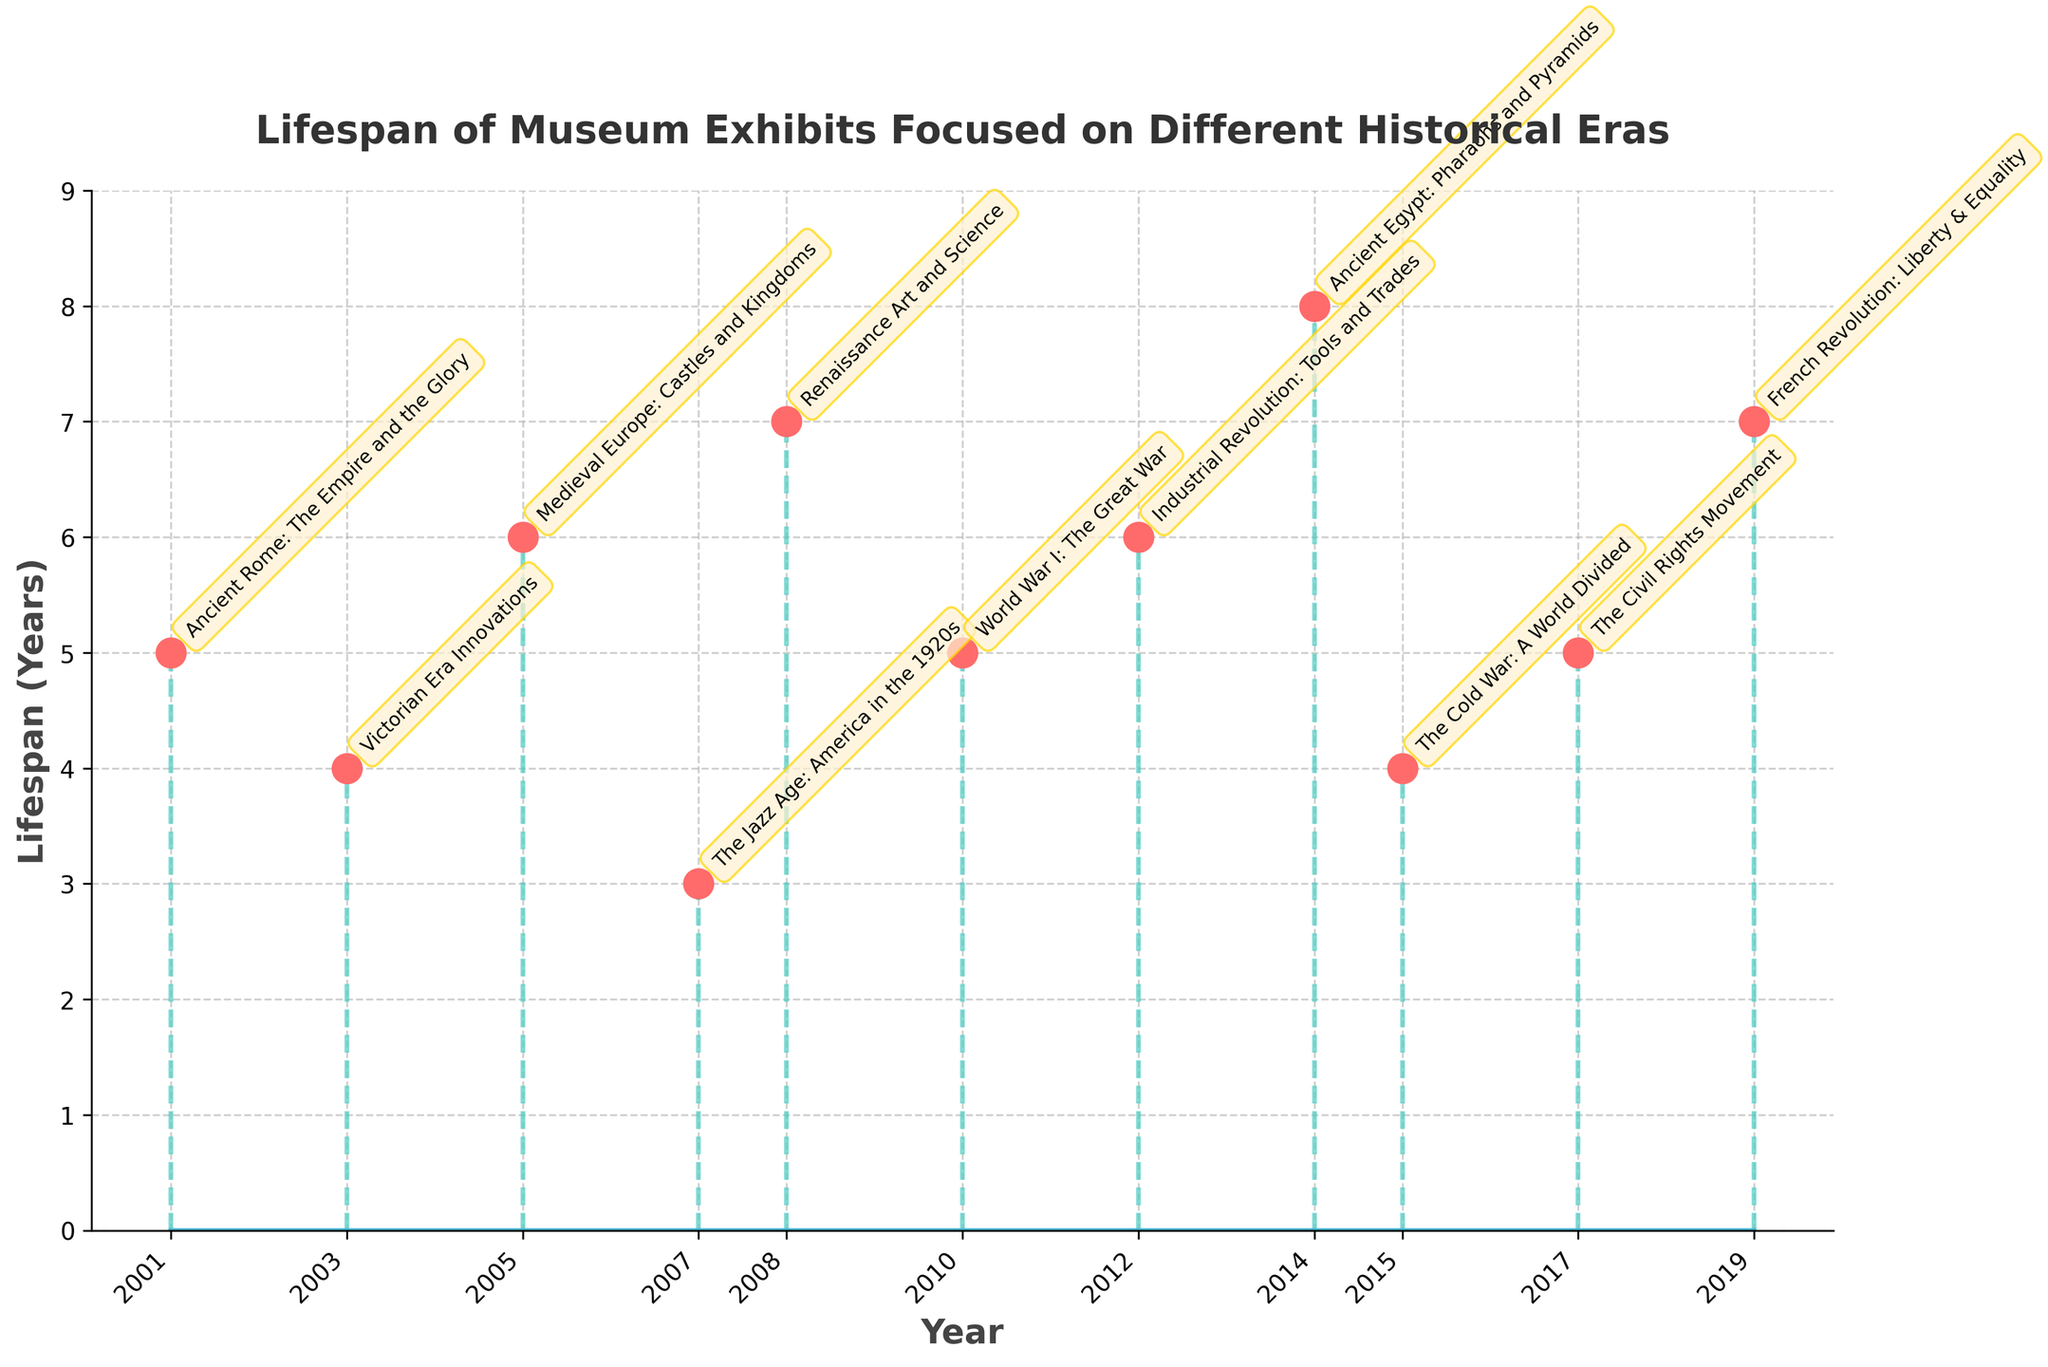What is the title of the figure? The title of the figure is usually found at the top and indicates the subject of the plot. It helps the viewer understand what the plot is about.
Answer: Lifespan of Museum Exhibits Focused on Different Historical Eras How many exhibits are represented in the figure? Count the number of unique data points or markers in the stem plot to determine the number of exhibits. Each stem represents a unique exhibit.
Answer: 11 Which exhibit has the longest lifespan? Identify the stem that extends the highest on the y-axis as it represents the exhibit with the maximum lifespan in years.
Answer: Ancient Egypt: Pharaohs and Pyramids What is the average lifespan of the exhibits? Sum the lifespans of all exhibits and divide by the number of exhibits: (5 + 4 + 6 + 3 + 7 + 5 + 6 + 8 + 4 + 5 + 7)/11 = 60/11 = 5.45.
Answer: 5.45 years Which exhibit started in the earliest year? Find the data point with the smallest x-value (year). This represents the earliest starting exhibit.
Answer: Ancient Rome: The Empire and the Glory What is the difference in lifespan between the exhibit "Ancient Rome: The Empire and the Glory" and "Renaissance Art and Science"? Subtract the lifespan of "Ancient Rome: The Empire and the Glory" from that of "Renaissance Art and Science": 7 - 5 = 2 years.
Answer: 2 years Which exhibits have the same lifespan? Identify data points where the y-values are identical to find exhibits with the same lifespan. "Ancient Rome: The Empire and the Glory," "World War I: The Great War," and "The Civil Rights Movement" all have a lifespan of 5 years.
Answer: Ancient Rome: The Empire and the Glory, World War I: The Great War, The Civil Rights Movement What pattern do you observe in the lifespans of the exhibits over the years? Observe the trend by examining how the y-values (lifespans) change across increasing x-values (years). There is no clear increasing or decreasing trend in the lifespans over the years—they vary independently.
Answer: Lifespans vary independently over the years Which years have the highest number of exhibits starting? Check the x-axis to count how many markers/stems start in the same year. Each year mentioned only has one exhibit starting, so each year has an equal number.
Answer: Each year has one exhibit starting Which historical era is represented by the shortest-lived exhibit, and what is its lifespan? Look for the shortest stem on the plot and identify its corresponding exhibit and its lifespan on the y-axis. "The Jazz Age: America in the 1920s" has the shortest lifespan of 3 years.
Answer: The Jazz Age: America in the 1920s, 3 years 